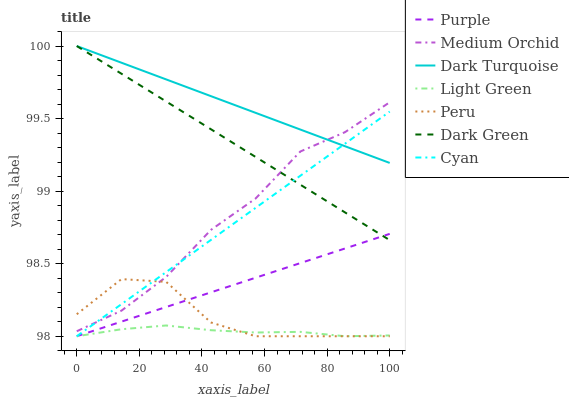Does Purple have the minimum area under the curve?
Answer yes or no. No. Does Purple have the maximum area under the curve?
Answer yes or no. No. Is Purple the smoothest?
Answer yes or no. No. Is Purple the roughest?
Answer yes or no. No. Does Dark Turquoise have the lowest value?
Answer yes or no. No. Does Purple have the highest value?
Answer yes or no. No. Is Peru less than Dark Turquoise?
Answer yes or no. Yes. Is Dark Turquoise greater than Light Green?
Answer yes or no. Yes. Does Peru intersect Dark Turquoise?
Answer yes or no. No. 